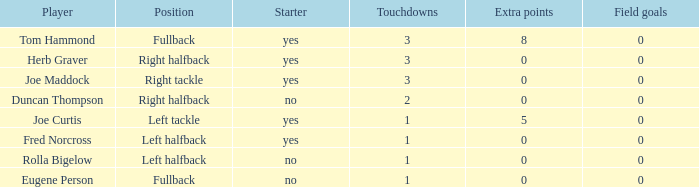What is the average number of field goals scored by a right halfback who had more than 3 touchdowns? None. 